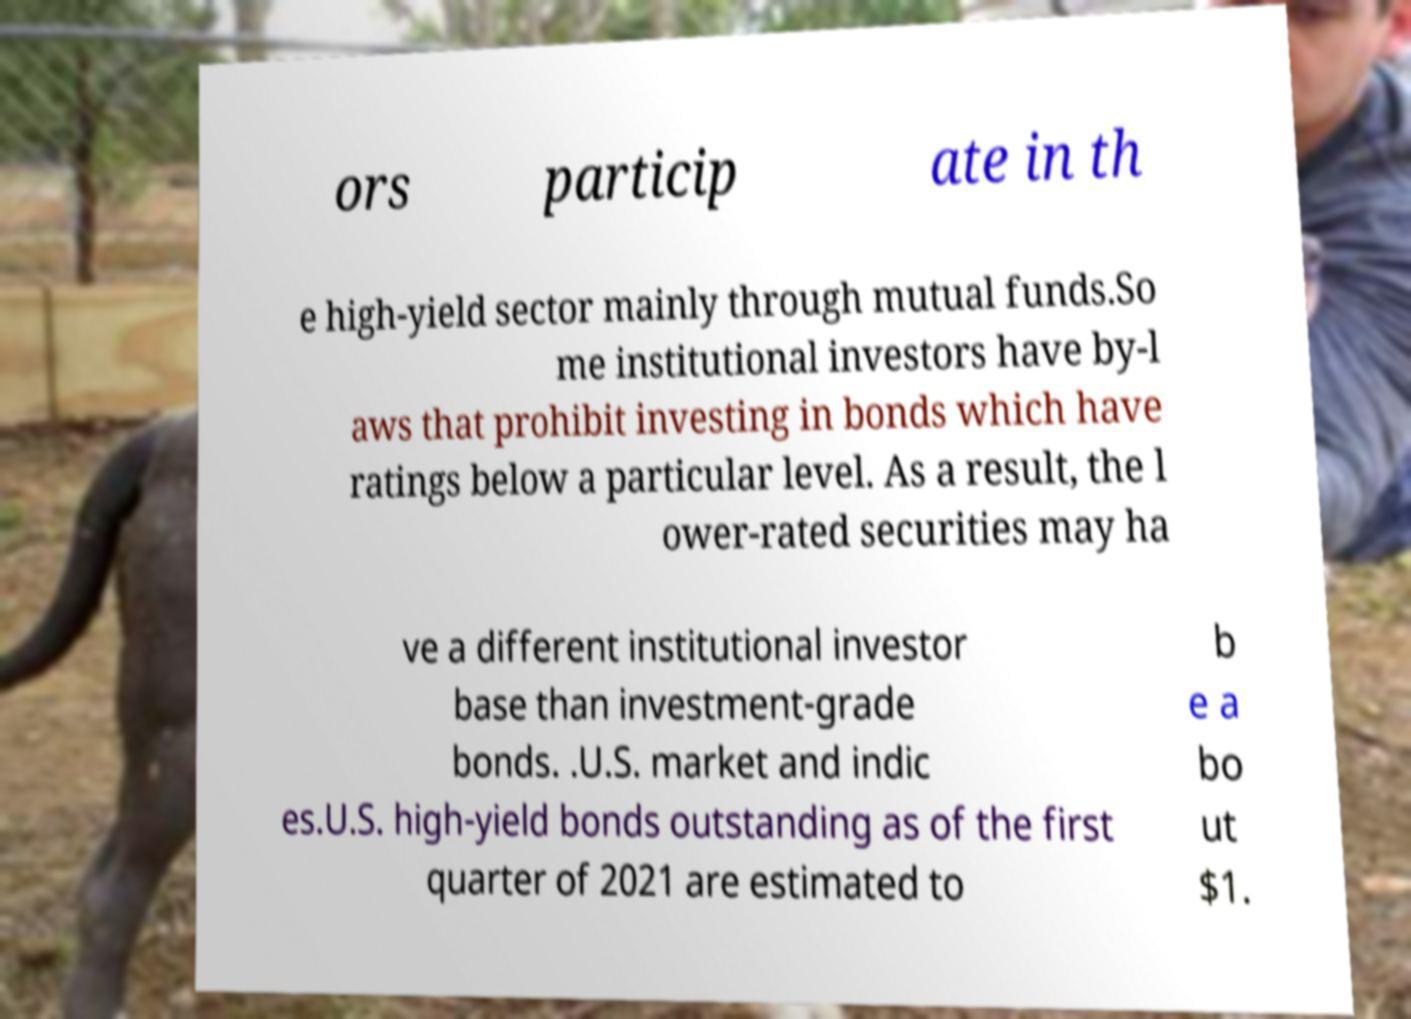Could you extract and type out the text from this image? ors particip ate in th e high-yield sector mainly through mutual funds.So me institutional investors have by-l aws that prohibit investing in bonds which have ratings below a particular level. As a result, the l ower-rated securities may ha ve a different institutional investor base than investment-grade bonds. .U.S. market and indic es.U.S. high-yield bonds outstanding as of the first quarter of 2021 are estimated to b e a bo ut $1. 